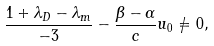<formula> <loc_0><loc_0><loc_500><loc_500>\frac { 1 + \lambda _ { D } - \lambda _ { m } } { - 3 } - \frac { \beta - \alpha } { c } u _ { 0 } \neq 0 ,</formula> 